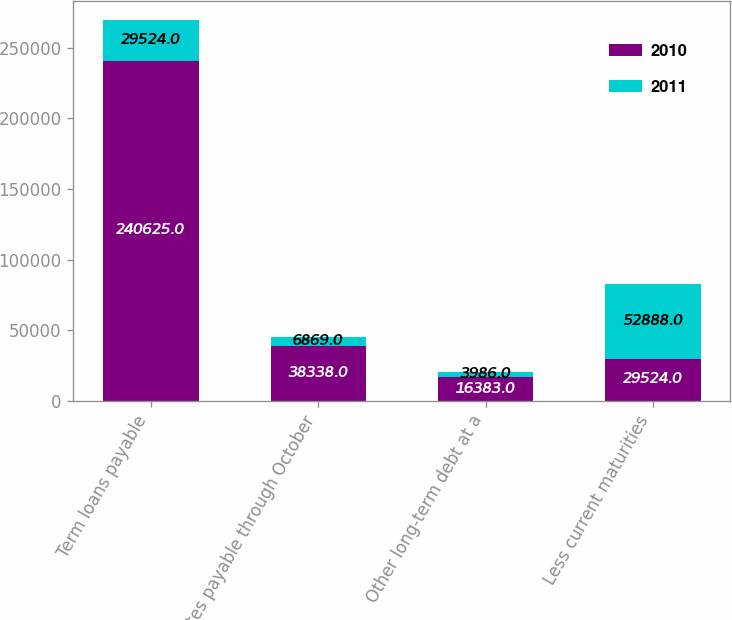Convert chart. <chart><loc_0><loc_0><loc_500><loc_500><stacked_bar_chart><ecel><fcel>Term loans payable<fcel>Notes payable through October<fcel>Other long-term debt at a<fcel>Less current maturities<nl><fcel>2010<fcel>240625<fcel>38338<fcel>16383<fcel>29524<nl><fcel>2011<fcel>29524<fcel>6869<fcel>3986<fcel>52888<nl></chart> 